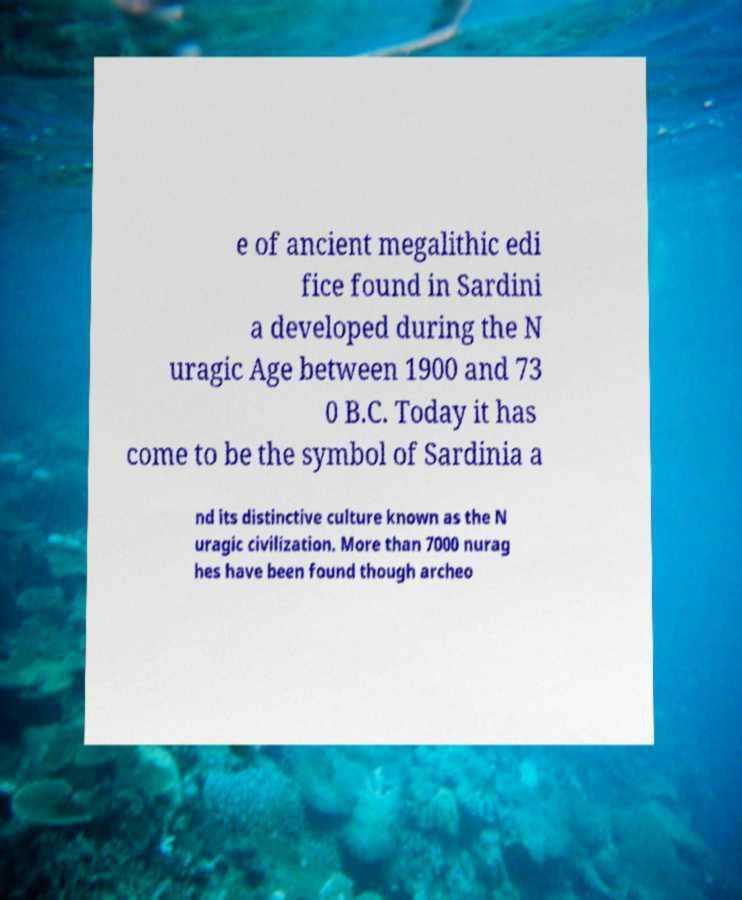There's text embedded in this image that I need extracted. Can you transcribe it verbatim? e of ancient megalithic edi fice found in Sardini a developed during the N uragic Age between 1900 and 73 0 B.C. Today it has come to be the symbol of Sardinia a nd its distinctive culture known as the N uragic civilization. More than 7000 nurag hes have been found though archeo 